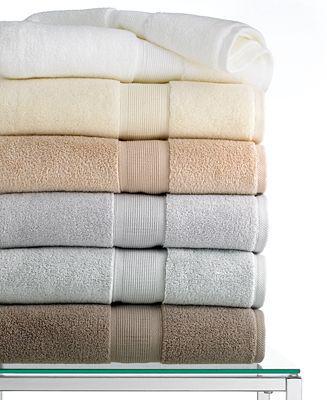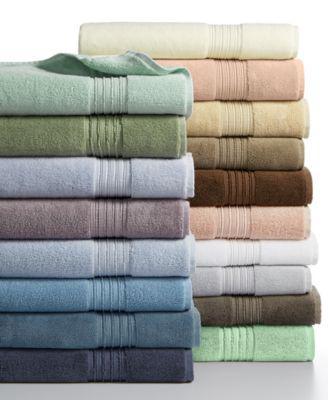The first image is the image on the left, the second image is the image on the right. Analyze the images presented: Is the assertion "The corners are pulled up on two towels." valid? Answer yes or no. Yes. The first image is the image on the left, the second image is the image on the right. Considering the images on both sides, is "There are two stacks of towels in the image on the right." valid? Answer yes or no. Yes. 